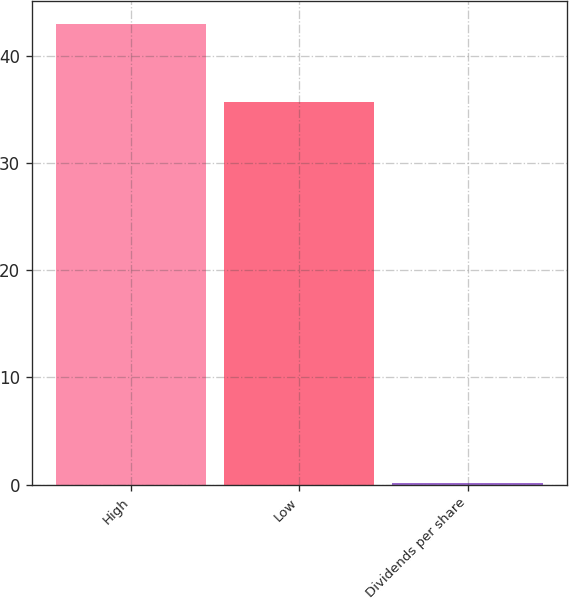Convert chart. <chart><loc_0><loc_0><loc_500><loc_500><bar_chart><fcel>High<fcel>Low<fcel>Dividends per share<nl><fcel>42.99<fcel>35.66<fcel>0.1<nl></chart> 